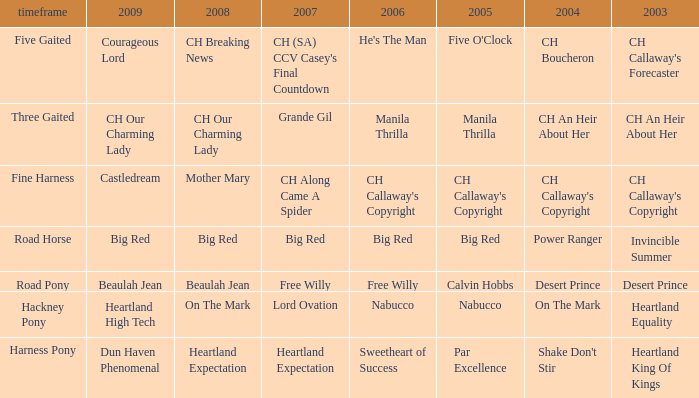What is the 2007 for the 2003 desert prince? Free Willy. 